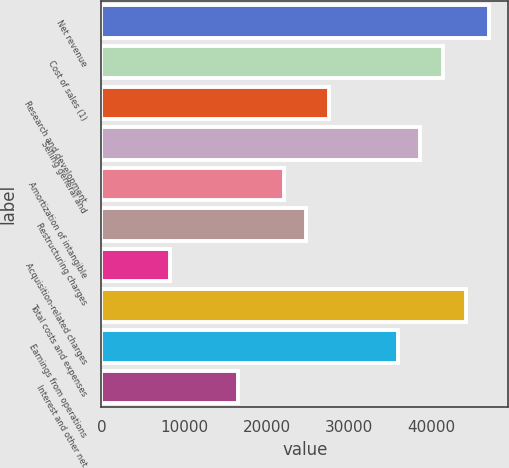Convert chart to OTSL. <chart><loc_0><loc_0><loc_500><loc_500><bar_chart><fcel>Net revenue<fcel>Cost of sales (1)<fcel>Research and development<fcel>Selling general and<fcel>Amortization of intangible<fcel>Restructuring charges<fcel>Acquisition-related charges<fcel>Total costs and expenses<fcel>Earnings from operations<fcel>Interest and other net<nl><fcel>46889.4<fcel>41373<fcel>27582<fcel>38614.8<fcel>22065.7<fcel>24823.8<fcel>8274.7<fcel>44131.2<fcel>35856.6<fcel>16549.3<nl></chart> 